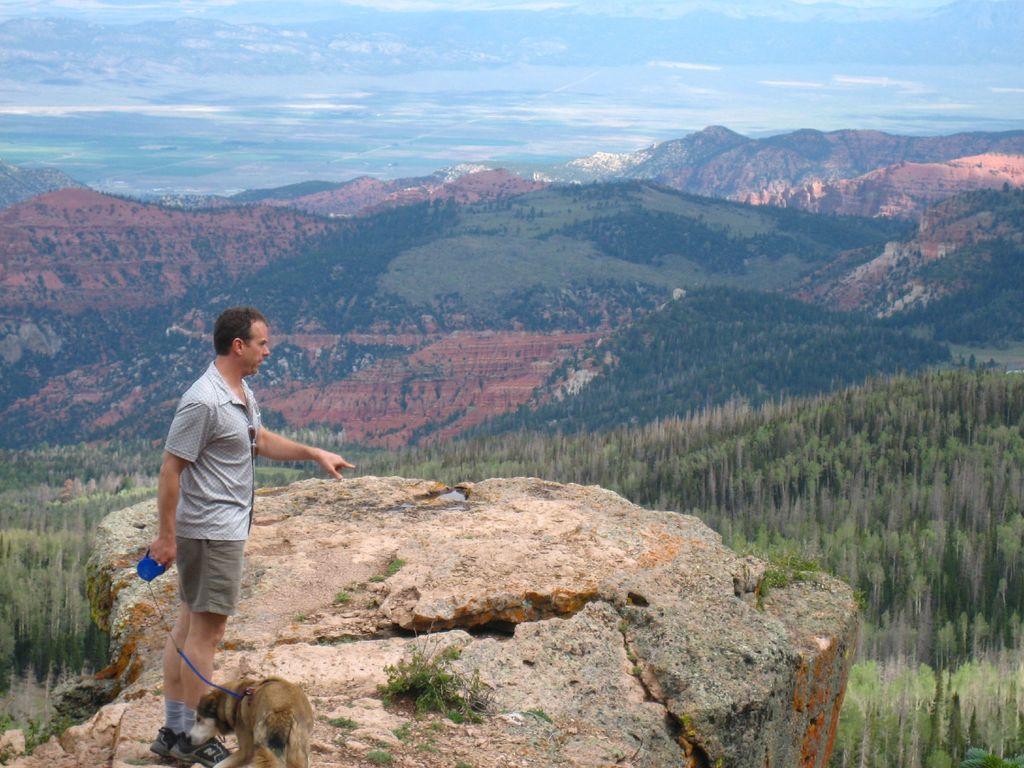How would you summarize this image in a sentence or two? In this image I can see a man standing on the mountain with a dog. I can also see blue color sky. 